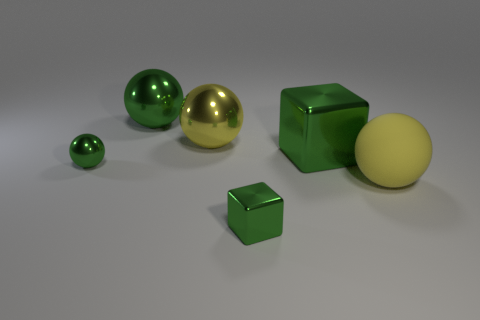Subtract all green balls. How many were subtracted if there are1green balls left? 1 Subtract all small green spheres. How many spheres are left? 3 Add 4 big gray rubber spheres. How many objects exist? 10 Subtract all green spheres. How many spheres are left? 2 Subtract 1 green spheres. How many objects are left? 5 Subtract all spheres. How many objects are left? 2 Subtract 1 cubes. How many cubes are left? 1 Subtract all blue spheres. Subtract all brown cubes. How many spheres are left? 4 Subtract all red spheres. How many gray cubes are left? 0 Subtract all small cyan cubes. Subtract all small green spheres. How many objects are left? 5 